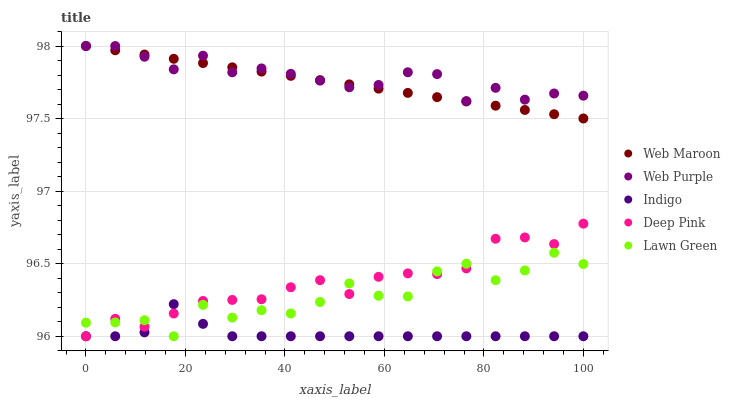Does Indigo have the minimum area under the curve?
Answer yes or no. Yes. Does Web Purple have the maximum area under the curve?
Answer yes or no. Yes. Does Deep Pink have the minimum area under the curve?
Answer yes or no. No. Does Deep Pink have the maximum area under the curve?
Answer yes or no. No. Is Web Maroon the smoothest?
Answer yes or no. Yes. Is Lawn Green the roughest?
Answer yes or no. Yes. Is Web Purple the smoothest?
Answer yes or no. No. Is Web Purple the roughest?
Answer yes or no. No. Does Indigo have the lowest value?
Answer yes or no. Yes. Does Web Purple have the lowest value?
Answer yes or no. No. Does Web Maroon have the highest value?
Answer yes or no. Yes. Does Deep Pink have the highest value?
Answer yes or no. No. Is Deep Pink less than Web Purple?
Answer yes or no. Yes. Is Web Purple greater than Indigo?
Answer yes or no. Yes. Does Deep Pink intersect Lawn Green?
Answer yes or no. Yes. Is Deep Pink less than Lawn Green?
Answer yes or no. No. Is Deep Pink greater than Lawn Green?
Answer yes or no. No. Does Deep Pink intersect Web Purple?
Answer yes or no. No. 